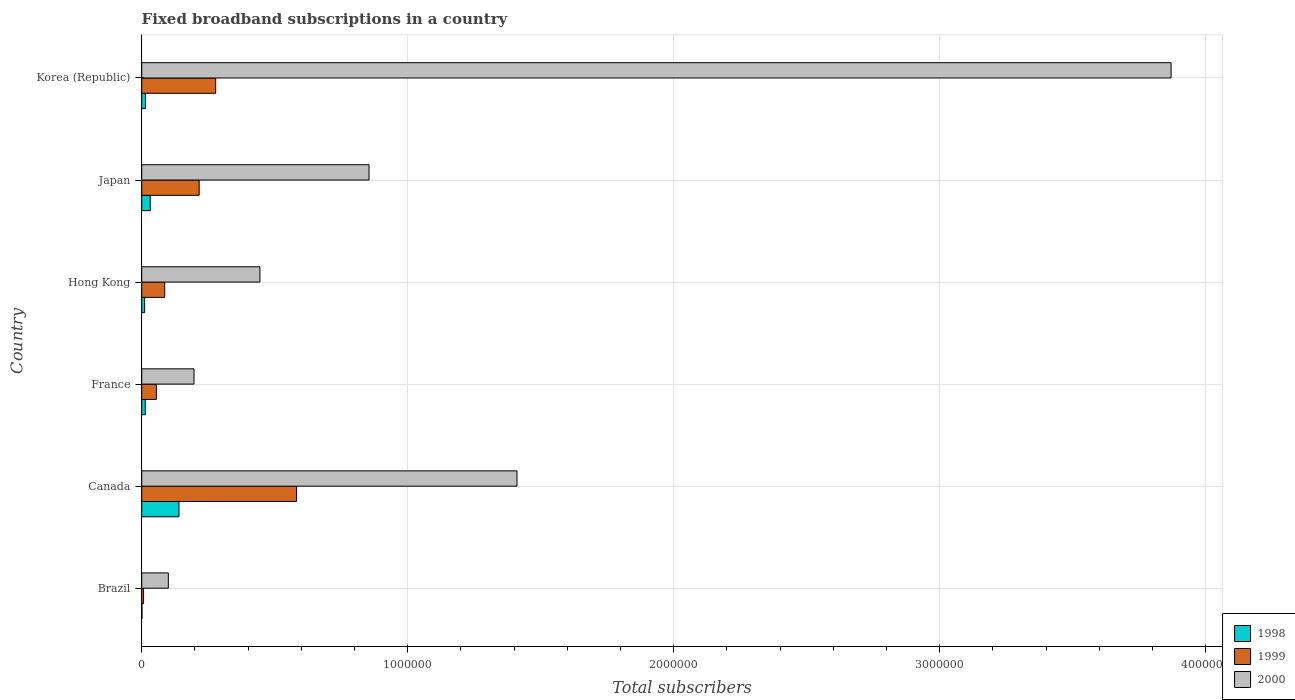How many bars are there on the 2nd tick from the bottom?
Ensure brevity in your answer.  3. In how many cases, is the number of bars for a given country not equal to the number of legend labels?
Provide a short and direct response. 0. Across all countries, what is the maximum number of broadband subscriptions in 1999?
Keep it short and to the point. 5.82e+05. In which country was the number of broadband subscriptions in 1998 maximum?
Ensure brevity in your answer.  Canada. What is the total number of broadband subscriptions in 1998 in the graph?
Offer a very short reply. 2.11e+05. What is the difference between the number of broadband subscriptions in 1998 in Brazil and that in Japan?
Provide a short and direct response. -3.10e+04. What is the difference between the number of broadband subscriptions in 2000 in Japan and the number of broadband subscriptions in 1999 in Canada?
Provide a short and direct response. 2.73e+05. What is the average number of broadband subscriptions in 2000 per country?
Your response must be concise. 1.15e+06. What is the difference between the number of broadband subscriptions in 1999 and number of broadband subscriptions in 1998 in Brazil?
Provide a succinct answer. 6000. What is the ratio of the number of broadband subscriptions in 2000 in Canada to that in Hong Kong?
Make the answer very short. 3.17. Is the number of broadband subscriptions in 2000 in Japan less than that in Korea (Republic)?
Your answer should be very brief. Yes. What is the difference between the highest and the second highest number of broadband subscriptions in 1998?
Make the answer very short. 1.08e+05. What is the difference between the highest and the lowest number of broadband subscriptions in 1998?
Provide a short and direct response. 1.39e+05. What does the 1st bar from the bottom in Brazil represents?
Provide a short and direct response. 1998. How many bars are there?
Give a very brief answer. 18. How many countries are there in the graph?
Your answer should be compact. 6. Are the values on the major ticks of X-axis written in scientific E-notation?
Make the answer very short. No. Does the graph contain any zero values?
Ensure brevity in your answer.  No. Does the graph contain grids?
Keep it short and to the point. Yes. What is the title of the graph?
Provide a succinct answer. Fixed broadband subscriptions in a country. What is the label or title of the X-axis?
Keep it short and to the point. Total subscribers. What is the label or title of the Y-axis?
Your answer should be compact. Country. What is the Total subscribers of 1998 in Brazil?
Provide a succinct answer. 1000. What is the Total subscribers of 1999 in Brazil?
Make the answer very short. 7000. What is the Total subscribers of 2000 in Brazil?
Keep it short and to the point. 1.00e+05. What is the Total subscribers of 1999 in Canada?
Give a very brief answer. 5.82e+05. What is the Total subscribers of 2000 in Canada?
Provide a short and direct response. 1.41e+06. What is the Total subscribers in 1998 in France?
Offer a terse response. 1.35e+04. What is the Total subscribers of 1999 in France?
Your response must be concise. 5.50e+04. What is the Total subscribers of 2000 in France?
Ensure brevity in your answer.  1.97e+05. What is the Total subscribers of 1998 in Hong Kong?
Make the answer very short. 1.10e+04. What is the Total subscribers in 1999 in Hong Kong?
Give a very brief answer. 8.65e+04. What is the Total subscribers in 2000 in Hong Kong?
Offer a terse response. 4.44e+05. What is the Total subscribers of 1998 in Japan?
Provide a succinct answer. 3.20e+04. What is the Total subscribers of 1999 in Japan?
Make the answer very short. 2.16e+05. What is the Total subscribers in 2000 in Japan?
Offer a very short reply. 8.55e+05. What is the Total subscribers in 1998 in Korea (Republic)?
Give a very brief answer. 1.40e+04. What is the Total subscribers of 1999 in Korea (Republic)?
Provide a succinct answer. 2.78e+05. What is the Total subscribers of 2000 in Korea (Republic)?
Your response must be concise. 3.87e+06. Across all countries, what is the maximum Total subscribers in 1999?
Offer a very short reply. 5.82e+05. Across all countries, what is the maximum Total subscribers of 2000?
Offer a terse response. 3.87e+06. Across all countries, what is the minimum Total subscribers of 1998?
Ensure brevity in your answer.  1000. Across all countries, what is the minimum Total subscribers in 1999?
Offer a very short reply. 7000. Across all countries, what is the minimum Total subscribers in 2000?
Give a very brief answer. 1.00e+05. What is the total Total subscribers of 1998 in the graph?
Your answer should be compact. 2.11e+05. What is the total Total subscribers in 1999 in the graph?
Ensure brevity in your answer.  1.22e+06. What is the total Total subscribers in 2000 in the graph?
Your answer should be very brief. 6.88e+06. What is the difference between the Total subscribers of 1998 in Brazil and that in Canada?
Keep it short and to the point. -1.39e+05. What is the difference between the Total subscribers of 1999 in Brazil and that in Canada?
Give a very brief answer. -5.75e+05. What is the difference between the Total subscribers of 2000 in Brazil and that in Canada?
Provide a succinct answer. -1.31e+06. What is the difference between the Total subscribers of 1998 in Brazil and that in France?
Give a very brief answer. -1.25e+04. What is the difference between the Total subscribers in 1999 in Brazil and that in France?
Offer a very short reply. -4.80e+04. What is the difference between the Total subscribers of 2000 in Brazil and that in France?
Give a very brief answer. -9.66e+04. What is the difference between the Total subscribers of 1998 in Brazil and that in Hong Kong?
Your answer should be very brief. -10000. What is the difference between the Total subscribers in 1999 in Brazil and that in Hong Kong?
Offer a very short reply. -7.95e+04. What is the difference between the Total subscribers of 2000 in Brazil and that in Hong Kong?
Keep it short and to the point. -3.44e+05. What is the difference between the Total subscribers in 1998 in Brazil and that in Japan?
Ensure brevity in your answer.  -3.10e+04. What is the difference between the Total subscribers in 1999 in Brazil and that in Japan?
Keep it short and to the point. -2.09e+05. What is the difference between the Total subscribers in 2000 in Brazil and that in Japan?
Your answer should be compact. -7.55e+05. What is the difference between the Total subscribers in 1998 in Brazil and that in Korea (Republic)?
Give a very brief answer. -1.30e+04. What is the difference between the Total subscribers in 1999 in Brazil and that in Korea (Republic)?
Offer a very short reply. -2.71e+05. What is the difference between the Total subscribers in 2000 in Brazil and that in Korea (Republic)?
Your answer should be compact. -3.77e+06. What is the difference between the Total subscribers of 1998 in Canada and that in France?
Your answer should be very brief. 1.27e+05. What is the difference between the Total subscribers in 1999 in Canada and that in France?
Your answer should be very brief. 5.27e+05. What is the difference between the Total subscribers of 2000 in Canada and that in France?
Provide a succinct answer. 1.21e+06. What is the difference between the Total subscribers in 1998 in Canada and that in Hong Kong?
Provide a succinct answer. 1.29e+05. What is the difference between the Total subscribers of 1999 in Canada and that in Hong Kong?
Provide a short and direct response. 4.96e+05. What is the difference between the Total subscribers of 2000 in Canada and that in Hong Kong?
Ensure brevity in your answer.  9.66e+05. What is the difference between the Total subscribers in 1998 in Canada and that in Japan?
Your answer should be compact. 1.08e+05. What is the difference between the Total subscribers in 1999 in Canada and that in Japan?
Ensure brevity in your answer.  3.66e+05. What is the difference between the Total subscribers in 2000 in Canada and that in Japan?
Give a very brief answer. 5.56e+05. What is the difference between the Total subscribers in 1998 in Canada and that in Korea (Republic)?
Ensure brevity in your answer.  1.26e+05. What is the difference between the Total subscribers in 1999 in Canada and that in Korea (Republic)?
Provide a succinct answer. 3.04e+05. What is the difference between the Total subscribers of 2000 in Canada and that in Korea (Republic)?
Your answer should be compact. -2.46e+06. What is the difference between the Total subscribers in 1998 in France and that in Hong Kong?
Give a very brief answer. 2464. What is the difference between the Total subscribers in 1999 in France and that in Hong Kong?
Offer a terse response. -3.15e+04. What is the difference between the Total subscribers in 2000 in France and that in Hong Kong?
Provide a short and direct response. -2.48e+05. What is the difference between the Total subscribers of 1998 in France and that in Japan?
Your answer should be very brief. -1.85e+04. What is the difference between the Total subscribers in 1999 in France and that in Japan?
Offer a terse response. -1.61e+05. What is the difference between the Total subscribers in 2000 in France and that in Japan?
Your answer should be very brief. -6.58e+05. What is the difference between the Total subscribers of 1998 in France and that in Korea (Republic)?
Ensure brevity in your answer.  -536. What is the difference between the Total subscribers of 1999 in France and that in Korea (Republic)?
Provide a succinct answer. -2.23e+05. What is the difference between the Total subscribers in 2000 in France and that in Korea (Republic)?
Provide a succinct answer. -3.67e+06. What is the difference between the Total subscribers in 1998 in Hong Kong and that in Japan?
Keep it short and to the point. -2.10e+04. What is the difference between the Total subscribers in 1999 in Hong Kong and that in Japan?
Your response must be concise. -1.30e+05. What is the difference between the Total subscribers of 2000 in Hong Kong and that in Japan?
Provide a short and direct response. -4.10e+05. What is the difference between the Total subscribers in 1998 in Hong Kong and that in Korea (Republic)?
Your answer should be very brief. -3000. What is the difference between the Total subscribers of 1999 in Hong Kong and that in Korea (Republic)?
Provide a short and direct response. -1.92e+05. What is the difference between the Total subscribers in 2000 in Hong Kong and that in Korea (Republic)?
Provide a succinct answer. -3.43e+06. What is the difference between the Total subscribers of 1998 in Japan and that in Korea (Republic)?
Keep it short and to the point. 1.80e+04. What is the difference between the Total subscribers in 1999 in Japan and that in Korea (Republic)?
Your answer should be very brief. -6.20e+04. What is the difference between the Total subscribers of 2000 in Japan and that in Korea (Republic)?
Offer a very short reply. -3.02e+06. What is the difference between the Total subscribers of 1998 in Brazil and the Total subscribers of 1999 in Canada?
Provide a short and direct response. -5.81e+05. What is the difference between the Total subscribers in 1998 in Brazil and the Total subscribers in 2000 in Canada?
Offer a terse response. -1.41e+06. What is the difference between the Total subscribers in 1999 in Brazil and the Total subscribers in 2000 in Canada?
Provide a succinct answer. -1.40e+06. What is the difference between the Total subscribers in 1998 in Brazil and the Total subscribers in 1999 in France?
Offer a terse response. -5.40e+04. What is the difference between the Total subscribers in 1998 in Brazil and the Total subscribers in 2000 in France?
Keep it short and to the point. -1.96e+05. What is the difference between the Total subscribers of 1999 in Brazil and the Total subscribers of 2000 in France?
Your answer should be compact. -1.90e+05. What is the difference between the Total subscribers in 1998 in Brazil and the Total subscribers in 1999 in Hong Kong?
Provide a succinct answer. -8.55e+04. What is the difference between the Total subscribers of 1998 in Brazil and the Total subscribers of 2000 in Hong Kong?
Provide a succinct answer. -4.43e+05. What is the difference between the Total subscribers in 1999 in Brazil and the Total subscribers in 2000 in Hong Kong?
Keep it short and to the point. -4.37e+05. What is the difference between the Total subscribers of 1998 in Brazil and the Total subscribers of 1999 in Japan?
Your response must be concise. -2.15e+05. What is the difference between the Total subscribers of 1998 in Brazil and the Total subscribers of 2000 in Japan?
Your answer should be very brief. -8.54e+05. What is the difference between the Total subscribers in 1999 in Brazil and the Total subscribers in 2000 in Japan?
Keep it short and to the point. -8.48e+05. What is the difference between the Total subscribers in 1998 in Brazil and the Total subscribers in 1999 in Korea (Republic)?
Make the answer very short. -2.77e+05. What is the difference between the Total subscribers in 1998 in Brazil and the Total subscribers in 2000 in Korea (Republic)?
Make the answer very short. -3.87e+06. What is the difference between the Total subscribers in 1999 in Brazil and the Total subscribers in 2000 in Korea (Republic)?
Your answer should be very brief. -3.86e+06. What is the difference between the Total subscribers of 1998 in Canada and the Total subscribers of 1999 in France?
Your response must be concise. 8.50e+04. What is the difference between the Total subscribers in 1998 in Canada and the Total subscribers in 2000 in France?
Make the answer very short. -5.66e+04. What is the difference between the Total subscribers of 1999 in Canada and the Total subscribers of 2000 in France?
Your answer should be very brief. 3.85e+05. What is the difference between the Total subscribers in 1998 in Canada and the Total subscribers in 1999 in Hong Kong?
Ensure brevity in your answer.  5.35e+04. What is the difference between the Total subscribers of 1998 in Canada and the Total subscribers of 2000 in Hong Kong?
Your answer should be very brief. -3.04e+05. What is the difference between the Total subscribers in 1999 in Canada and the Total subscribers in 2000 in Hong Kong?
Offer a terse response. 1.38e+05. What is the difference between the Total subscribers of 1998 in Canada and the Total subscribers of 1999 in Japan?
Ensure brevity in your answer.  -7.60e+04. What is the difference between the Total subscribers of 1998 in Canada and the Total subscribers of 2000 in Japan?
Ensure brevity in your answer.  -7.15e+05. What is the difference between the Total subscribers of 1999 in Canada and the Total subscribers of 2000 in Japan?
Provide a succinct answer. -2.73e+05. What is the difference between the Total subscribers in 1998 in Canada and the Total subscribers in 1999 in Korea (Republic)?
Make the answer very short. -1.38e+05. What is the difference between the Total subscribers of 1998 in Canada and the Total subscribers of 2000 in Korea (Republic)?
Offer a terse response. -3.73e+06. What is the difference between the Total subscribers in 1999 in Canada and the Total subscribers in 2000 in Korea (Republic)?
Keep it short and to the point. -3.29e+06. What is the difference between the Total subscribers of 1998 in France and the Total subscribers of 1999 in Hong Kong?
Your answer should be very brief. -7.30e+04. What is the difference between the Total subscribers in 1998 in France and the Total subscribers in 2000 in Hong Kong?
Provide a succinct answer. -4.31e+05. What is the difference between the Total subscribers of 1999 in France and the Total subscribers of 2000 in Hong Kong?
Your answer should be very brief. -3.89e+05. What is the difference between the Total subscribers of 1998 in France and the Total subscribers of 1999 in Japan?
Ensure brevity in your answer.  -2.03e+05. What is the difference between the Total subscribers in 1998 in France and the Total subscribers in 2000 in Japan?
Your answer should be very brief. -8.41e+05. What is the difference between the Total subscribers in 1999 in France and the Total subscribers in 2000 in Japan?
Provide a short and direct response. -8.00e+05. What is the difference between the Total subscribers in 1998 in France and the Total subscribers in 1999 in Korea (Republic)?
Your answer should be compact. -2.65e+05. What is the difference between the Total subscribers in 1998 in France and the Total subscribers in 2000 in Korea (Republic)?
Provide a short and direct response. -3.86e+06. What is the difference between the Total subscribers in 1999 in France and the Total subscribers in 2000 in Korea (Republic)?
Your answer should be very brief. -3.82e+06. What is the difference between the Total subscribers in 1998 in Hong Kong and the Total subscribers in 1999 in Japan?
Offer a very short reply. -2.05e+05. What is the difference between the Total subscribers of 1998 in Hong Kong and the Total subscribers of 2000 in Japan?
Keep it short and to the point. -8.44e+05. What is the difference between the Total subscribers in 1999 in Hong Kong and the Total subscribers in 2000 in Japan?
Keep it short and to the point. -7.68e+05. What is the difference between the Total subscribers in 1998 in Hong Kong and the Total subscribers in 1999 in Korea (Republic)?
Ensure brevity in your answer.  -2.67e+05. What is the difference between the Total subscribers in 1998 in Hong Kong and the Total subscribers in 2000 in Korea (Republic)?
Provide a short and direct response. -3.86e+06. What is the difference between the Total subscribers in 1999 in Hong Kong and the Total subscribers in 2000 in Korea (Republic)?
Offer a terse response. -3.78e+06. What is the difference between the Total subscribers in 1998 in Japan and the Total subscribers in 1999 in Korea (Republic)?
Your response must be concise. -2.46e+05. What is the difference between the Total subscribers in 1998 in Japan and the Total subscribers in 2000 in Korea (Republic)?
Your answer should be compact. -3.84e+06. What is the difference between the Total subscribers in 1999 in Japan and the Total subscribers in 2000 in Korea (Republic)?
Ensure brevity in your answer.  -3.65e+06. What is the average Total subscribers of 1998 per country?
Provide a short and direct response. 3.52e+04. What is the average Total subscribers in 1999 per country?
Provide a short and direct response. 2.04e+05. What is the average Total subscribers in 2000 per country?
Keep it short and to the point. 1.15e+06. What is the difference between the Total subscribers of 1998 and Total subscribers of 1999 in Brazil?
Offer a terse response. -6000. What is the difference between the Total subscribers in 1998 and Total subscribers in 2000 in Brazil?
Your answer should be compact. -9.90e+04. What is the difference between the Total subscribers of 1999 and Total subscribers of 2000 in Brazil?
Your response must be concise. -9.30e+04. What is the difference between the Total subscribers of 1998 and Total subscribers of 1999 in Canada?
Offer a terse response. -4.42e+05. What is the difference between the Total subscribers of 1998 and Total subscribers of 2000 in Canada?
Provide a succinct answer. -1.27e+06. What is the difference between the Total subscribers of 1999 and Total subscribers of 2000 in Canada?
Your response must be concise. -8.29e+05. What is the difference between the Total subscribers in 1998 and Total subscribers in 1999 in France?
Give a very brief answer. -4.15e+04. What is the difference between the Total subscribers in 1998 and Total subscribers in 2000 in France?
Provide a short and direct response. -1.83e+05. What is the difference between the Total subscribers of 1999 and Total subscribers of 2000 in France?
Give a very brief answer. -1.42e+05. What is the difference between the Total subscribers in 1998 and Total subscribers in 1999 in Hong Kong?
Offer a terse response. -7.55e+04. What is the difference between the Total subscribers of 1998 and Total subscribers of 2000 in Hong Kong?
Provide a short and direct response. -4.33e+05. What is the difference between the Total subscribers in 1999 and Total subscribers in 2000 in Hong Kong?
Your answer should be compact. -3.58e+05. What is the difference between the Total subscribers in 1998 and Total subscribers in 1999 in Japan?
Offer a terse response. -1.84e+05. What is the difference between the Total subscribers in 1998 and Total subscribers in 2000 in Japan?
Offer a terse response. -8.23e+05. What is the difference between the Total subscribers in 1999 and Total subscribers in 2000 in Japan?
Keep it short and to the point. -6.39e+05. What is the difference between the Total subscribers in 1998 and Total subscribers in 1999 in Korea (Republic)?
Ensure brevity in your answer.  -2.64e+05. What is the difference between the Total subscribers in 1998 and Total subscribers in 2000 in Korea (Republic)?
Your response must be concise. -3.86e+06. What is the difference between the Total subscribers of 1999 and Total subscribers of 2000 in Korea (Republic)?
Offer a terse response. -3.59e+06. What is the ratio of the Total subscribers in 1998 in Brazil to that in Canada?
Provide a short and direct response. 0.01. What is the ratio of the Total subscribers in 1999 in Brazil to that in Canada?
Offer a very short reply. 0.01. What is the ratio of the Total subscribers of 2000 in Brazil to that in Canada?
Your response must be concise. 0.07. What is the ratio of the Total subscribers of 1998 in Brazil to that in France?
Keep it short and to the point. 0.07. What is the ratio of the Total subscribers in 1999 in Brazil to that in France?
Give a very brief answer. 0.13. What is the ratio of the Total subscribers of 2000 in Brazil to that in France?
Offer a very short reply. 0.51. What is the ratio of the Total subscribers of 1998 in Brazil to that in Hong Kong?
Your answer should be compact. 0.09. What is the ratio of the Total subscribers in 1999 in Brazil to that in Hong Kong?
Your response must be concise. 0.08. What is the ratio of the Total subscribers of 2000 in Brazil to that in Hong Kong?
Offer a terse response. 0.23. What is the ratio of the Total subscribers of 1998 in Brazil to that in Japan?
Ensure brevity in your answer.  0.03. What is the ratio of the Total subscribers in 1999 in Brazil to that in Japan?
Your response must be concise. 0.03. What is the ratio of the Total subscribers in 2000 in Brazil to that in Japan?
Provide a short and direct response. 0.12. What is the ratio of the Total subscribers of 1998 in Brazil to that in Korea (Republic)?
Keep it short and to the point. 0.07. What is the ratio of the Total subscribers in 1999 in Brazil to that in Korea (Republic)?
Your answer should be compact. 0.03. What is the ratio of the Total subscribers of 2000 in Brazil to that in Korea (Republic)?
Offer a terse response. 0.03. What is the ratio of the Total subscribers in 1998 in Canada to that in France?
Your answer should be compact. 10.4. What is the ratio of the Total subscribers in 1999 in Canada to that in France?
Your response must be concise. 10.58. What is the ratio of the Total subscribers of 2000 in Canada to that in France?
Ensure brevity in your answer.  7.18. What is the ratio of the Total subscribers in 1998 in Canada to that in Hong Kong?
Your answer should be compact. 12.73. What is the ratio of the Total subscribers of 1999 in Canada to that in Hong Kong?
Provide a succinct answer. 6.73. What is the ratio of the Total subscribers in 2000 in Canada to that in Hong Kong?
Your answer should be compact. 3.17. What is the ratio of the Total subscribers in 1998 in Canada to that in Japan?
Keep it short and to the point. 4.38. What is the ratio of the Total subscribers in 1999 in Canada to that in Japan?
Your answer should be very brief. 2.69. What is the ratio of the Total subscribers in 2000 in Canada to that in Japan?
Offer a terse response. 1.65. What is the ratio of the Total subscribers in 1998 in Canada to that in Korea (Republic)?
Ensure brevity in your answer.  10. What is the ratio of the Total subscribers of 1999 in Canada to that in Korea (Republic)?
Your response must be concise. 2.09. What is the ratio of the Total subscribers of 2000 in Canada to that in Korea (Republic)?
Provide a succinct answer. 0.36. What is the ratio of the Total subscribers in 1998 in France to that in Hong Kong?
Give a very brief answer. 1.22. What is the ratio of the Total subscribers in 1999 in France to that in Hong Kong?
Provide a short and direct response. 0.64. What is the ratio of the Total subscribers of 2000 in France to that in Hong Kong?
Your answer should be compact. 0.44. What is the ratio of the Total subscribers in 1998 in France to that in Japan?
Provide a succinct answer. 0.42. What is the ratio of the Total subscribers of 1999 in France to that in Japan?
Provide a succinct answer. 0.25. What is the ratio of the Total subscribers in 2000 in France to that in Japan?
Your answer should be compact. 0.23. What is the ratio of the Total subscribers in 1998 in France to that in Korea (Republic)?
Your response must be concise. 0.96. What is the ratio of the Total subscribers of 1999 in France to that in Korea (Republic)?
Give a very brief answer. 0.2. What is the ratio of the Total subscribers in 2000 in France to that in Korea (Republic)?
Offer a very short reply. 0.05. What is the ratio of the Total subscribers in 1998 in Hong Kong to that in Japan?
Ensure brevity in your answer.  0.34. What is the ratio of the Total subscribers of 1999 in Hong Kong to that in Japan?
Keep it short and to the point. 0.4. What is the ratio of the Total subscribers in 2000 in Hong Kong to that in Japan?
Offer a very short reply. 0.52. What is the ratio of the Total subscribers of 1998 in Hong Kong to that in Korea (Republic)?
Give a very brief answer. 0.79. What is the ratio of the Total subscribers in 1999 in Hong Kong to that in Korea (Republic)?
Your response must be concise. 0.31. What is the ratio of the Total subscribers in 2000 in Hong Kong to that in Korea (Republic)?
Your answer should be compact. 0.11. What is the ratio of the Total subscribers of 1998 in Japan to that in Korea (Republic)?
Your answer should be very brief. 2.29. What is the ratio of the Total subscribers of 1999 in Japan to that in Korea (Republic)?
Offer a terse response. 0.78. What is the ratio of the Total subscribers of 2000 in Japan to that in Korea (Republic)?
Your response must be concise. 0.22. What is the difference between the highest and the second highest Total subscribers of 1998?
Your answer should be very brief. 1.08e+05. What is the difference between the highest and the second highest Total subscribers of 1999?
Your answer should be compact. 3.04e+05. What is the difference between the highest and the second highest Total subscribers in 2000?
Provide a succinct answer. 2.46e+06. What is the difference between the highest and the lowest Total subscribers of 1998?
Give a very brief answer. 1.39e+05. What is the difference between the highest and the lowest Total subscribers in 1999?
Provide a succinct answer. 5.75e+05. What is the difference between the highest and the lowest Total subscribers in 2000?
Offer a very short reply. 3.77e+06. 